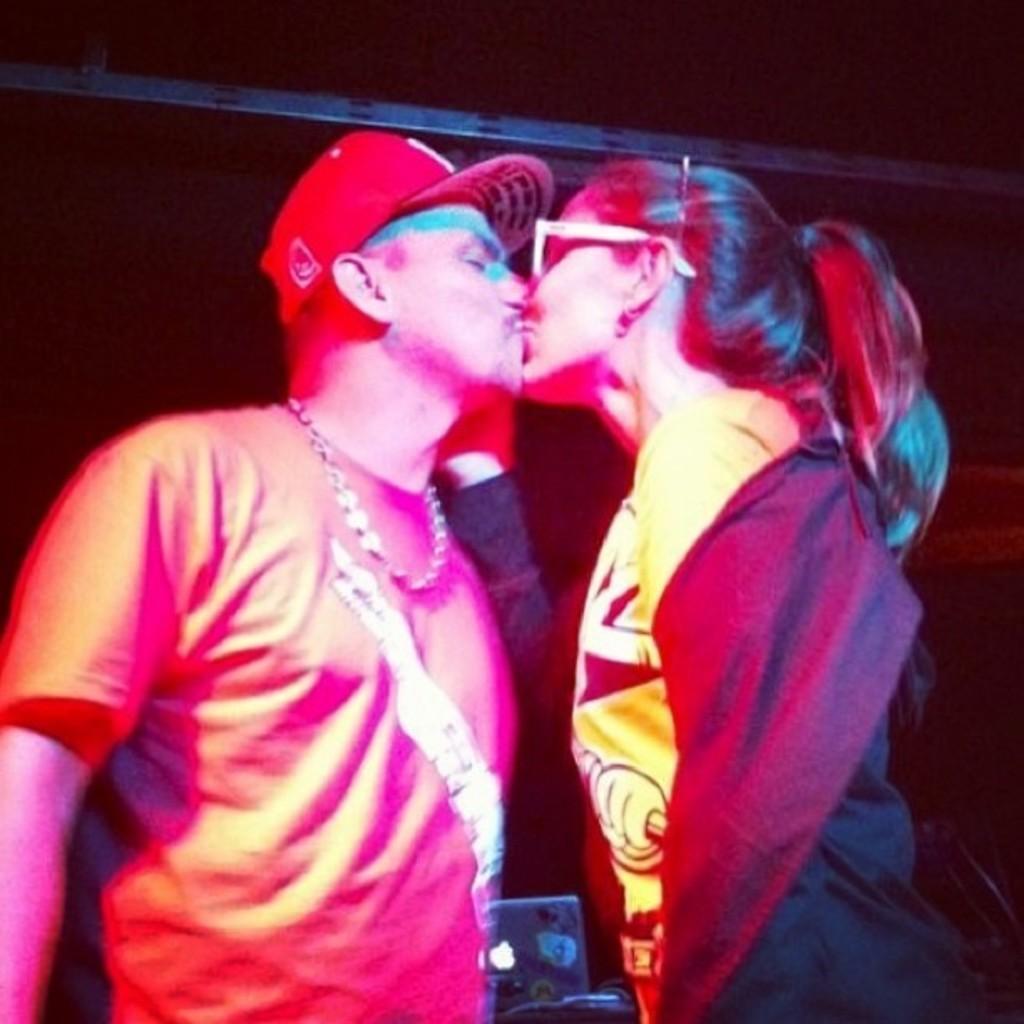Could you give a brief overview of what you see in this image? This image consists of two persons. On the left, the man is wearing a red T-shirt and a red cap. On the right, we can see a woman wearing a black jacket. At the top, there is a roof. In the middle, it looks like a laptop. 